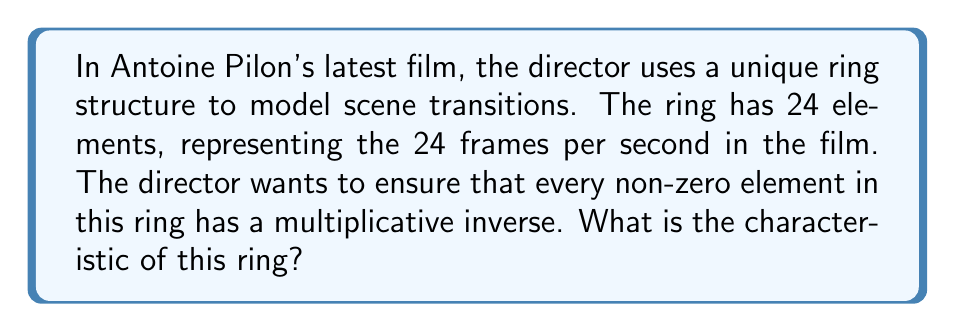Can you solve this math problem? To solve this problem, we need to consider the properties of rings and their characteristics:

1) First, recall that a ring with unity in which every non-zero element has a multiplicative inverse is called a field.

2) The only finite fields are those with $p^n$ elements, where $p$ is a prime number and $n$ is a positive integer.

3) In this case, we have 24 elements in our ring. We need to determine if 24 can be expressed as $p^n$ for some prime $p$ and positive integer $n$.

4) 24 can be factored as $2^3 \times 3$. This is not of the form $p^n$, so our ring cannot be a field.

5) Therefore, not every non-zero element in this ring has a multiplicative inverse.

6) The characteristic of a ring is the smallest positive integer $n$ such that $n \cdot 1 = 0$ in the ring, where $1$ is the multiplicative identity. If no such positive integer exists, the ring is said to have characteristic 0.

7) In this case, since we have 24 elements, we know that $24 \cdot 1 = 0$ in the ring.

8) However, we need to find the smallest such positive integer. The factors of 24 are 1, 2, 3, 4, 6, 8, 12, and 24.

9) By checking these in order, we find that $12 \cdot 1 = 0$ in this ring, and this is the smallest such positive integer.

Therefore, the characteristic of this ring is 12.
Answer: The characteristic of the ring is 12. 